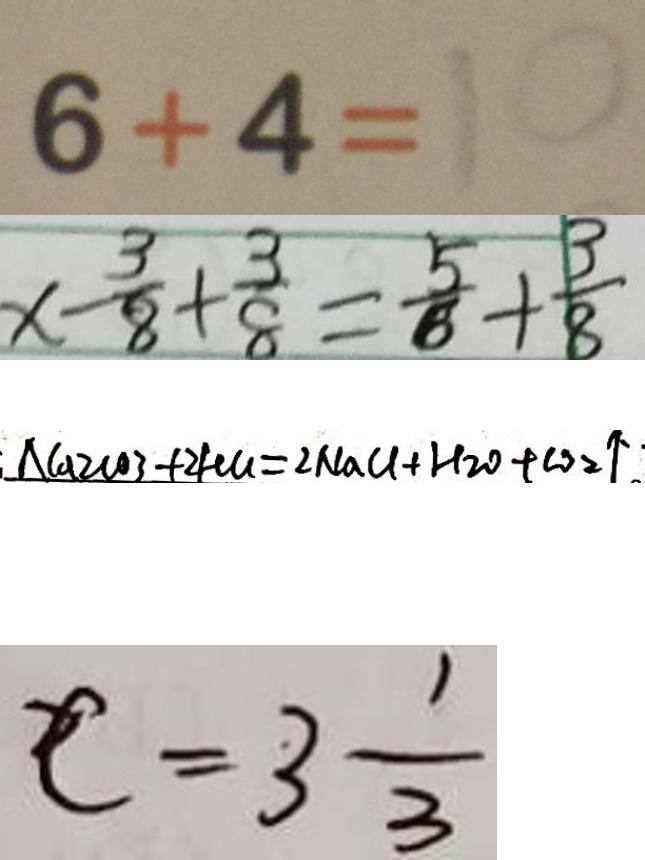<formula> <loc_0><loc_0><loc_500><loc_500>6 + 4 = 1 0 
 x - \frac { 3 } { 8 } + \frac { 3 } { 8 } = \frac { 5 } { 8 } + \frac { 3 } { 8 } 
 : N a _ { 2 } C O 3 + 2 H C l = 2 N a C l + H _ { 2 } 0 + C O _ { 2 } \uparrow 
 c = 3 \frac { 1 } { 3 }</formula> 